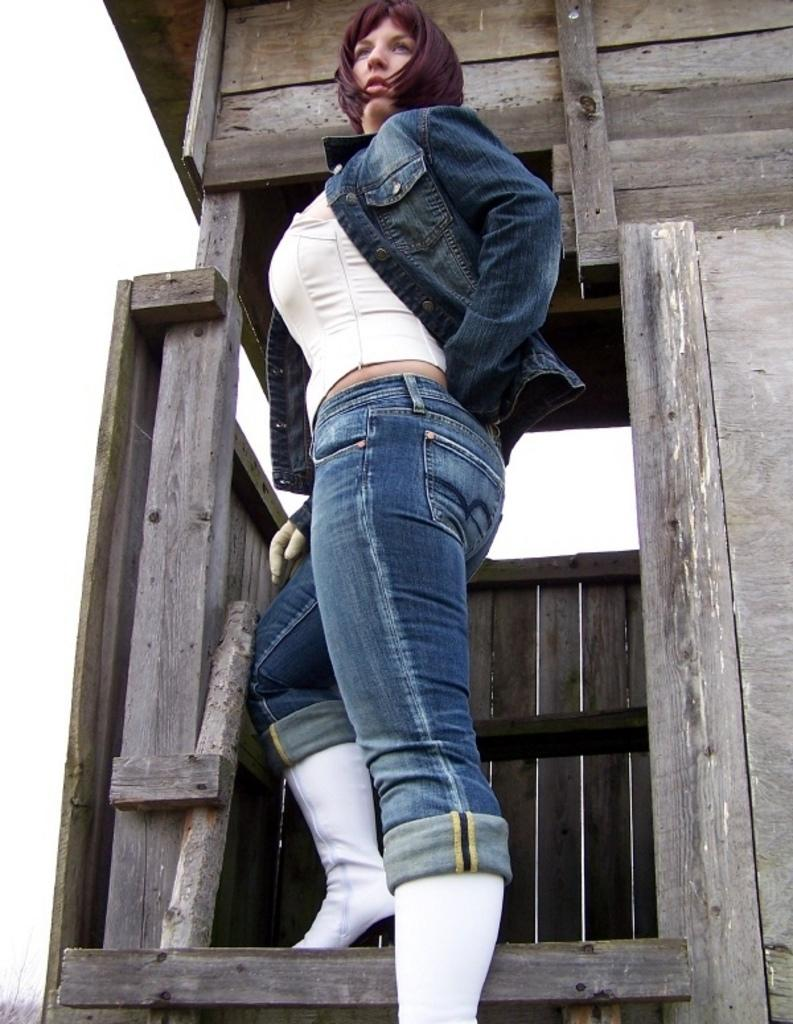Who is the main subject in the image? There is a lady standing in the center of the image. What can be seen in the background of the image? There is a wooden house and the sky visible in the background of the image. Are there any plants or vegetation in the image? Yes, there are trees in the bottom left corner of the image. What type of shoe is the bear wearing in the image? There is no bear or shoe present in the image. 